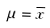Convert formula to latex. <formula><loc_0><loc_0><loc_500><loc_500>\mu = \overline { x }</formula> 